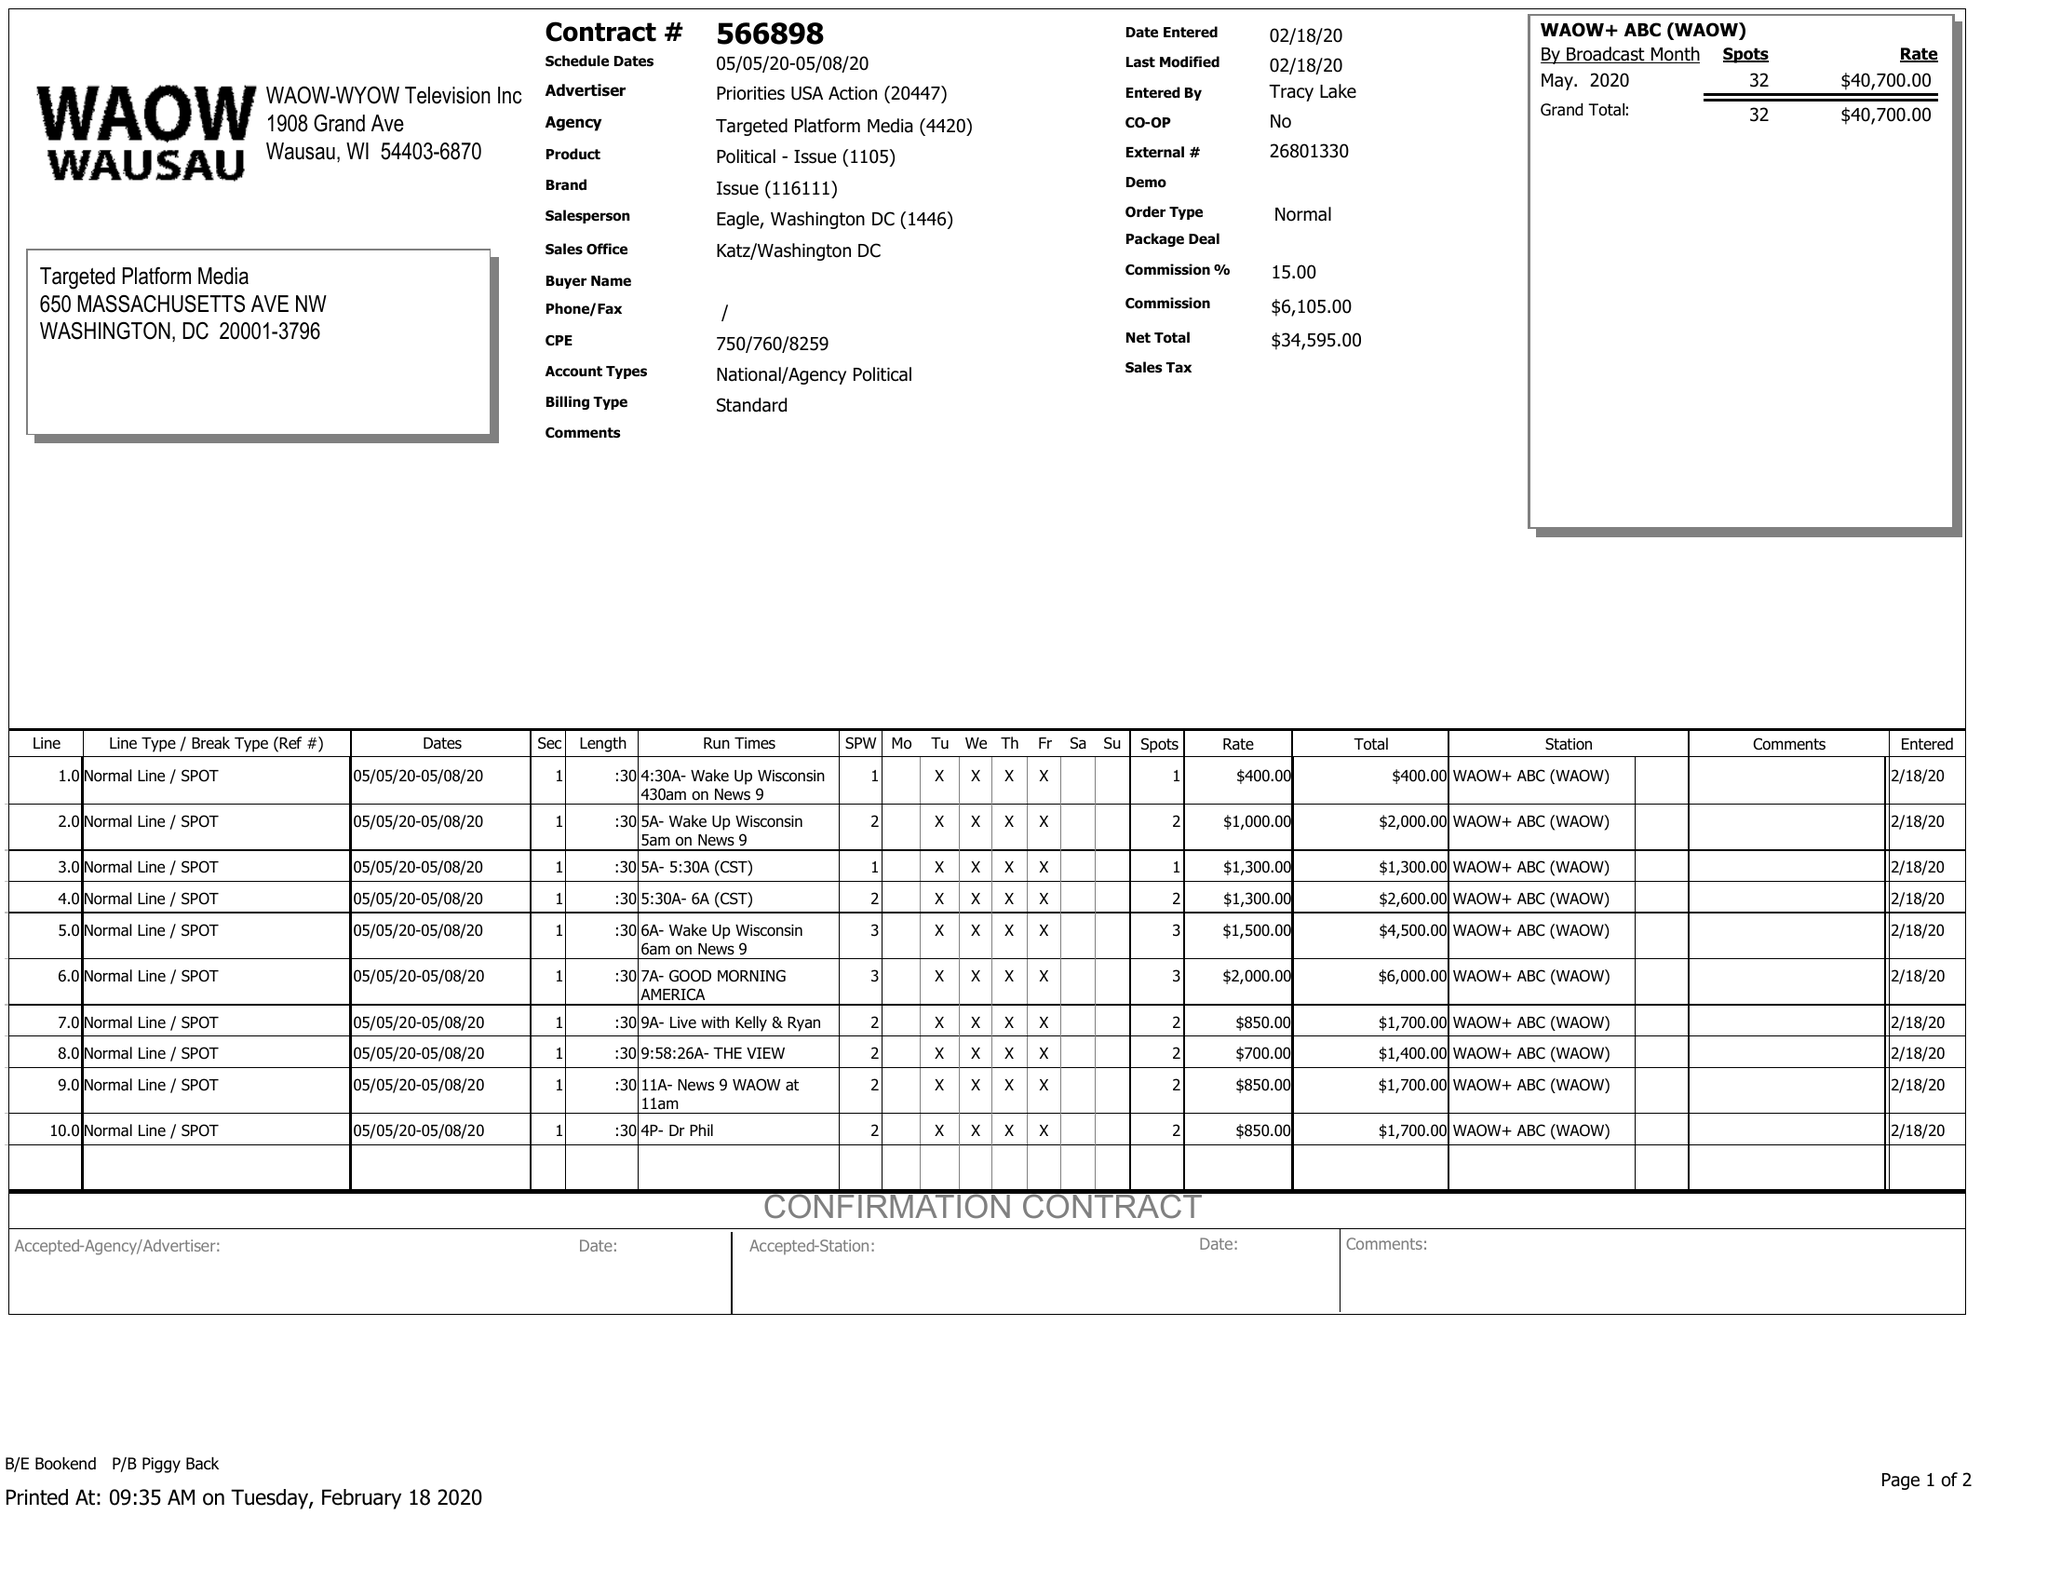What is the value for the flight_to?
Answer the question using a single word or phrase. 05/08/20 